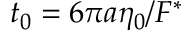Convert formula to latex. <formula><loc_0><loc_0><loc_500><loc_500>t _ { 0 } = 6 \pi a \eta _ { 0 } / F ^ { \ast }</formula> 